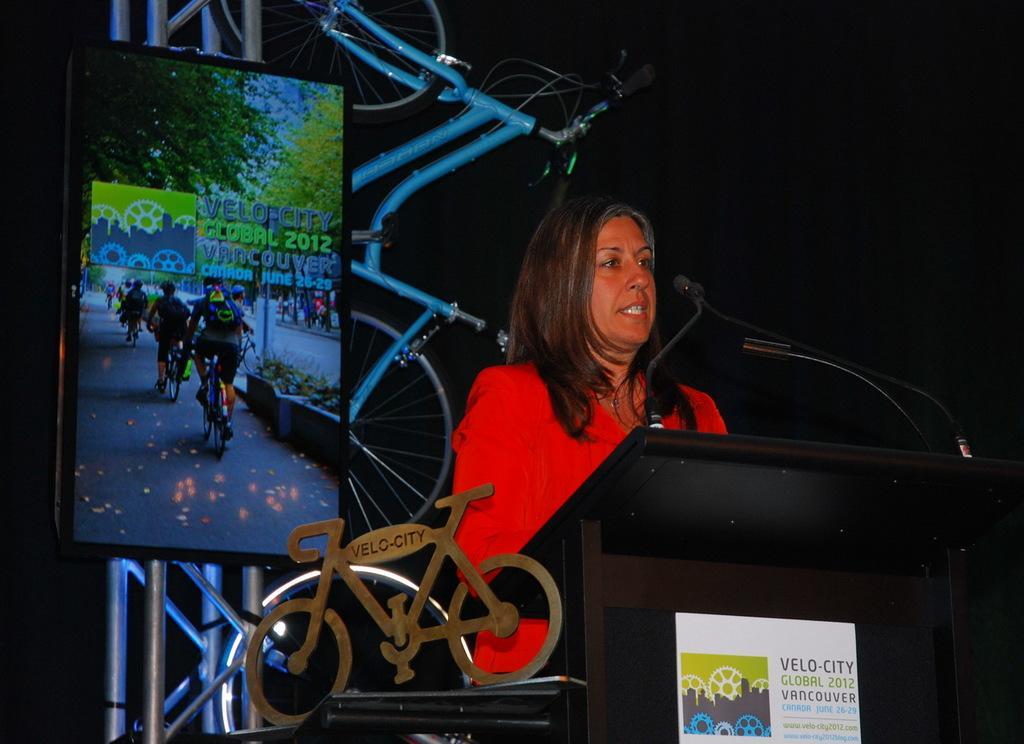Can you describe this image briefly? In this image we can see a woman standing in front of the podium, on the podium, we can see the mics and a poster with some text and image, behind her we can see a bicycle, also we can see a toy bicycle and a board with some text and images and the background is dark. 